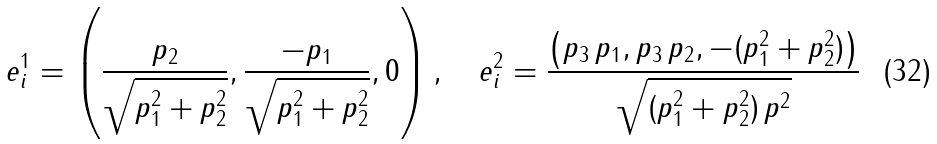Convert formula to latex. <formula><loc_0><loc_0><loc_500><loc_500>e ^ { 1 } _ { i } = \left ( \frac { p _ { 2 } } { \sqrt { p _ { 1 } ^ { 2 } + p _ { 2 } ^ { 2 } } } , \frac { - p _ { 1 } } { \sqrt { p _ { 1 } ^ { 2 } + p _ { 2 } ^ { 2 } } } , 0 \right ) , \quad e ^ { 2 } _ { i } = \frac { \left ( p _ { 3 } \, p _ { 1 } , p _ { 3 } \, p _ { 2 } , - ( p _ { 1 } ^ { 2 } + p _ { 2 } ^ { 2 } ) \right ) } { \sqrt { ( p _ { 1 } ^ { 2 } + p _ { 2 } ^ { 2 } ) \, p ^ { 2 } } }</formula> 